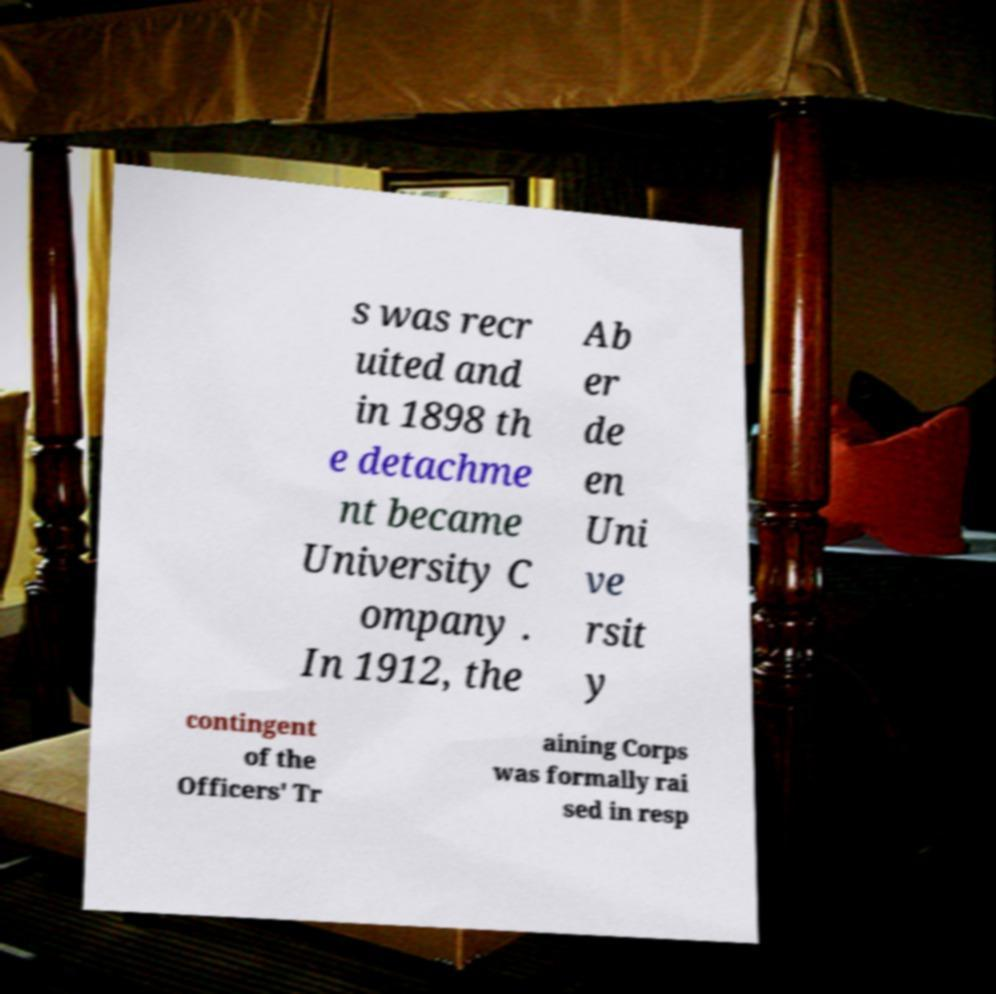For documentation purposes, I need the text within this image transcribed. Could you provide that? s was recr uited and in 1898 th e detachme nt became University C ompany . In 1912, the Ab er de en Uni ve rsit y contingent of the Officers' Tr aining Corps was formally rai sed in resp 